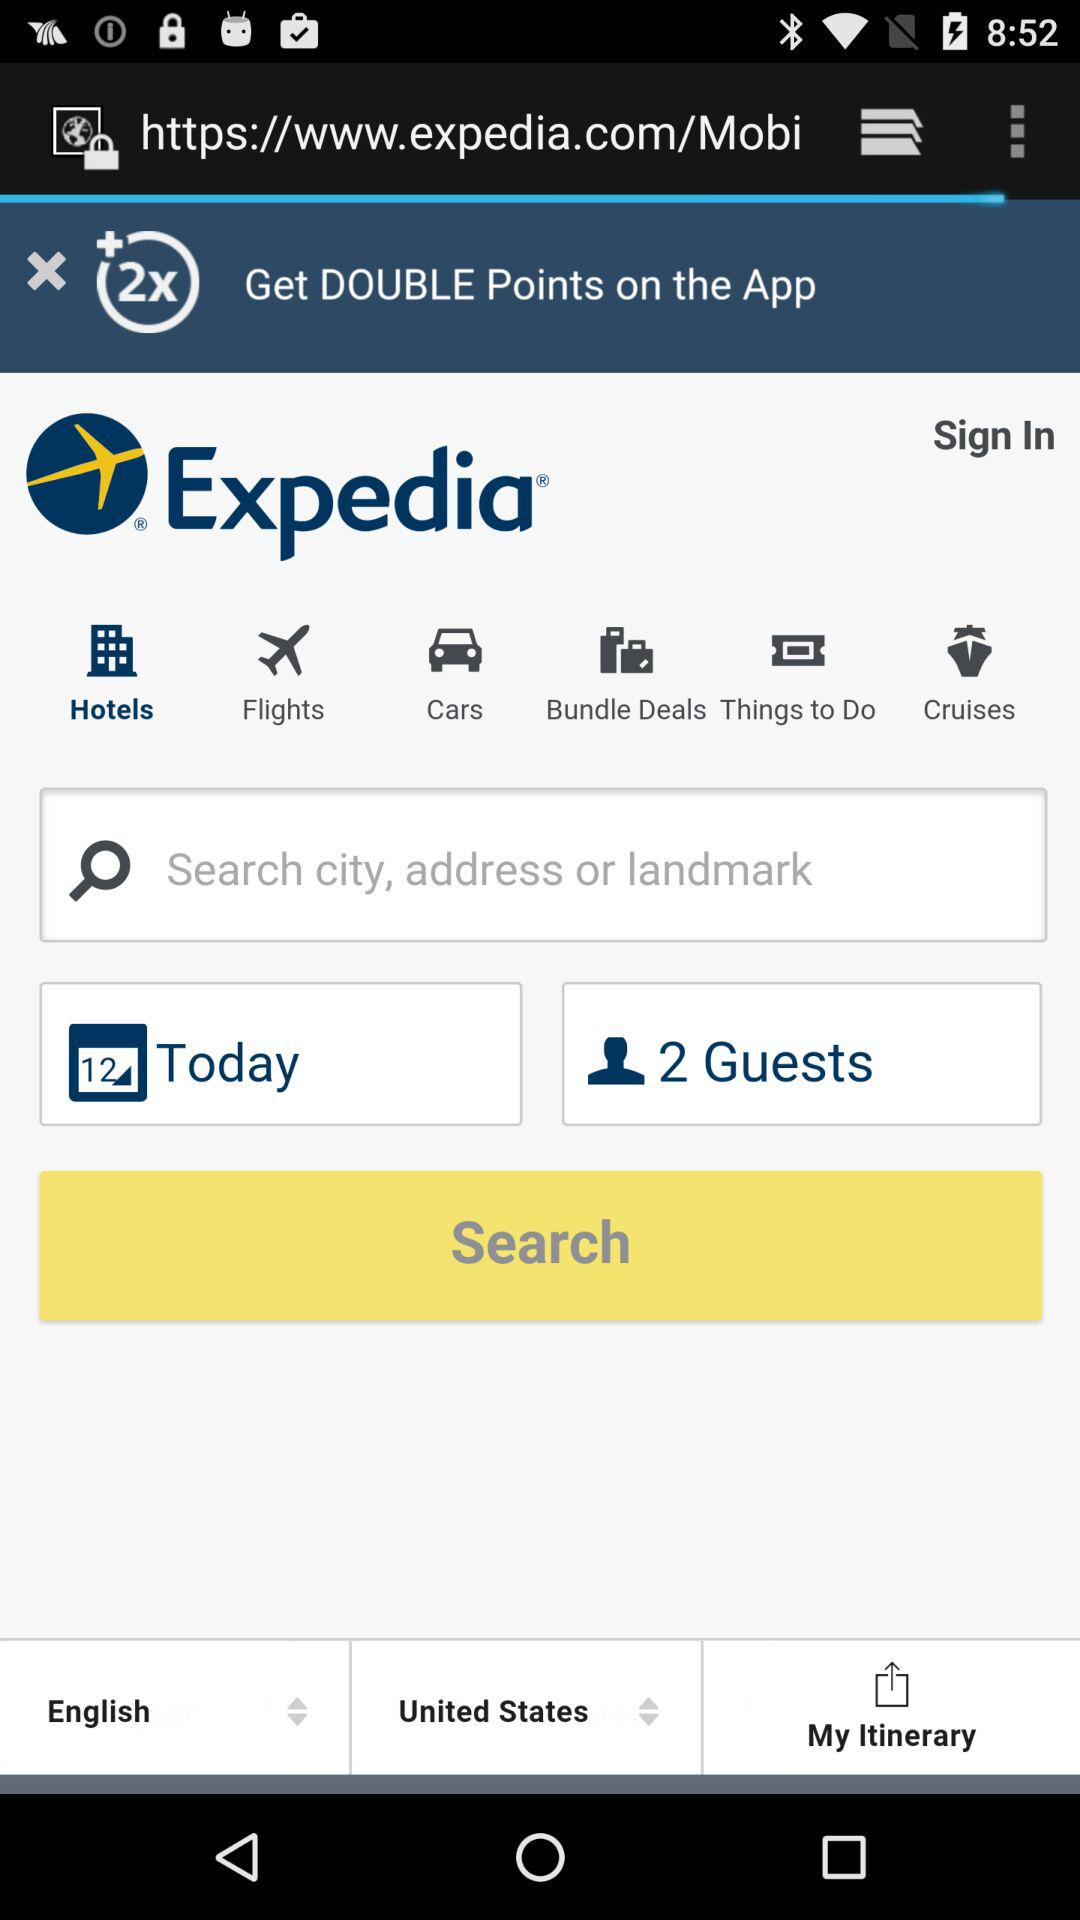How many people are selected in the search bar?
Answer the question using a single word or phrase. 2 